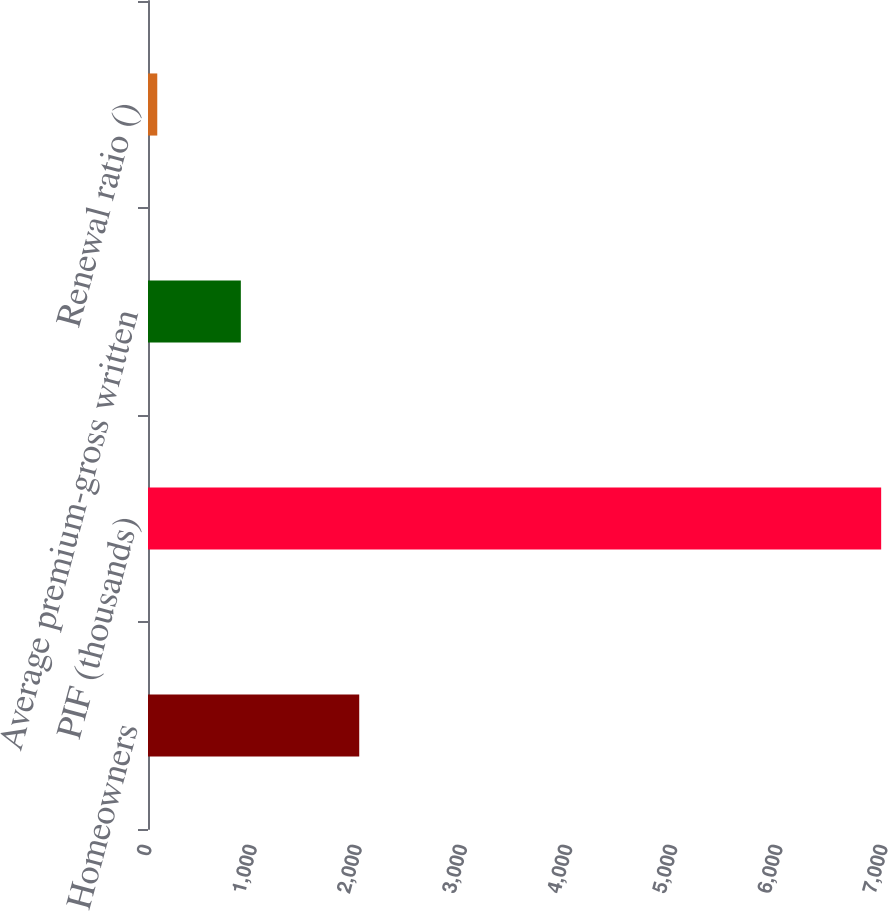<chart> <loc_0><loc_0><loc_500><loc_500><bar_chart><fcel>Homeowners<fcel>PIF (thousands)<fcel>Average premium-gross written<fcel>Renewal ratio ()<nl><fcel>2009<fcel>6973<fcel>883<fcel>88.1<nl></chart> 